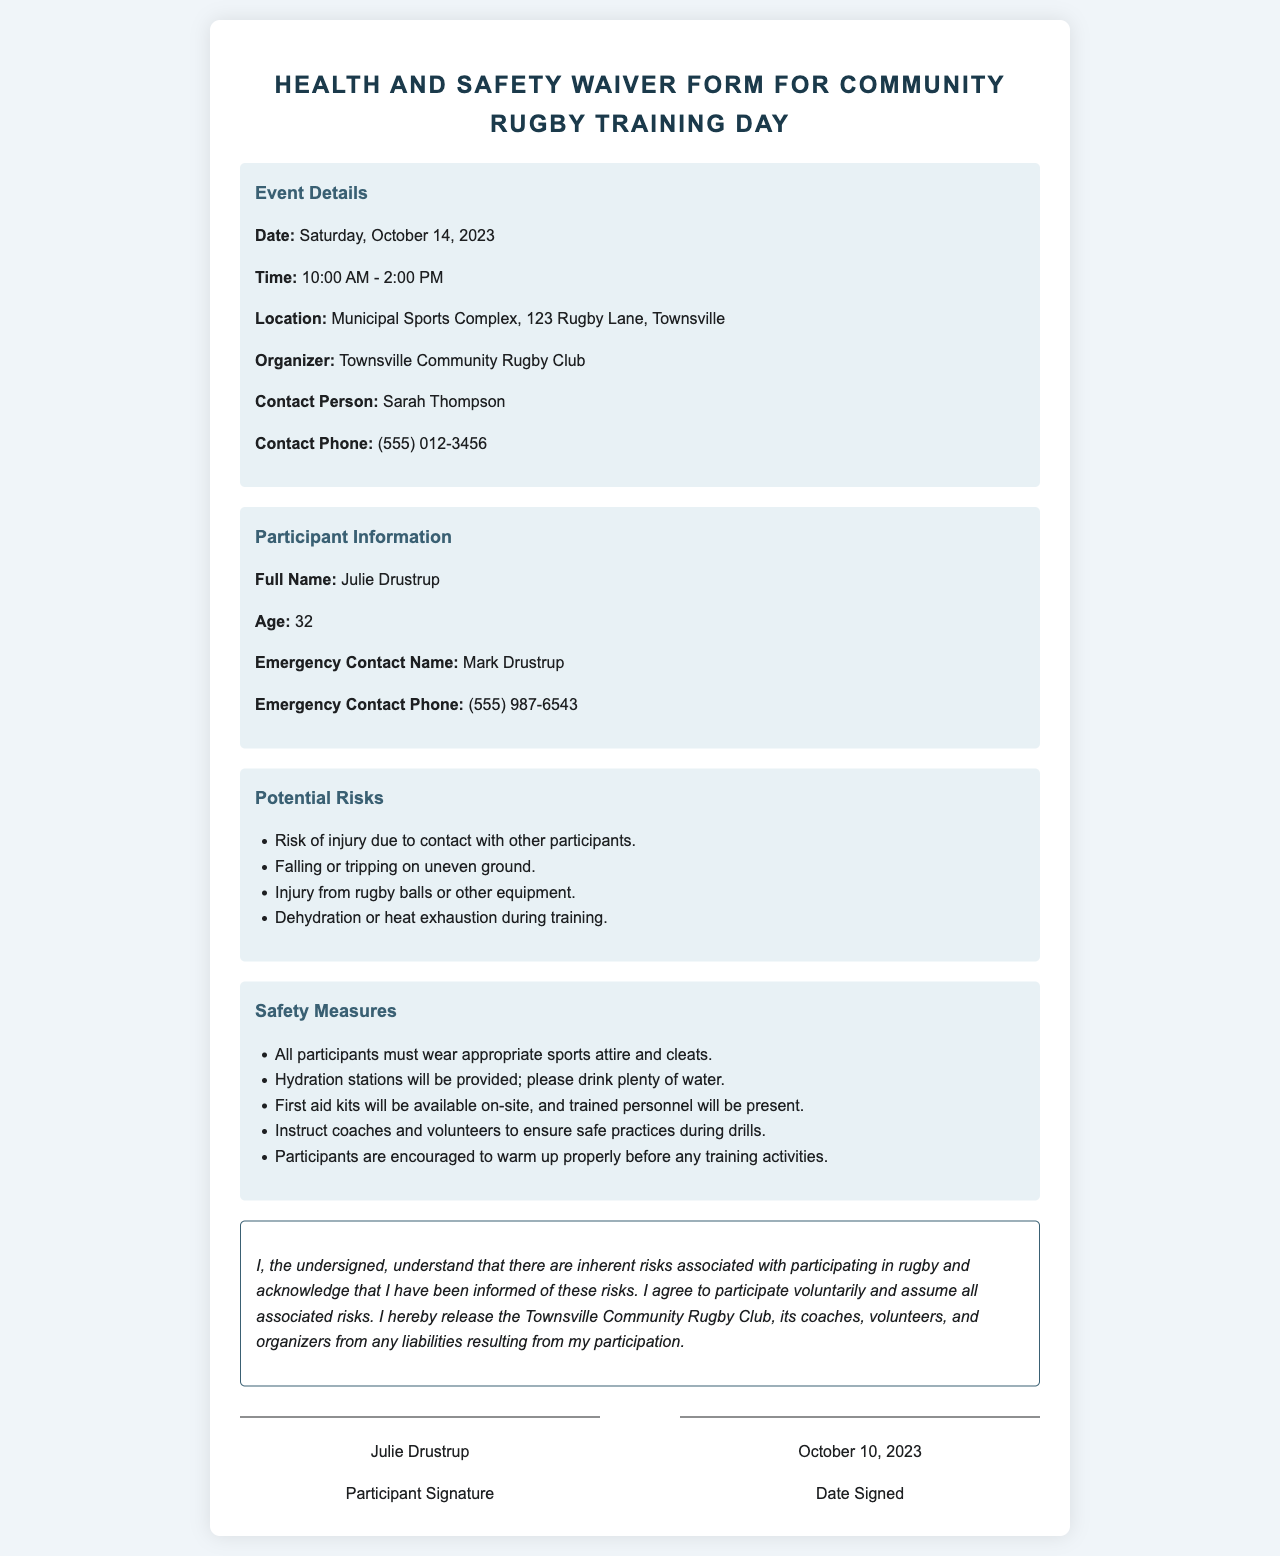What is the event date? The event date is specifically mentioned in the event details section of the document.
Answer: Saturday, October 14, 2023 What are the potential risks listed? The document outlines several potential risks associated with the event.
Answer: Injury due to contact, falling or tripping, injury from balls or equipment, dehydration Who is the contact person for the event? The contact person’s name is listed in the event details section.
Answer: Sarah Thompson What should participants wear? The safety measures specify the required attire for participants.
Answer: Appropriate sports attire and cleats When was the waiver signed? The date signed is located in the signature line section of the document.
Answer: October 10, 2023 What is the location of the training day? The location is stated in the event details.
Answer: Municipal Sports Complex, 123 Rugby Lane, Townsville What type of training measures are encouraged? The document contains specific safety measures regarding training practices.
Answer: Warm up properly before activities Who can be contacted in case of an emergency? The emergency contact is provided in the participant info section.
Answer: Mark Drustrup 